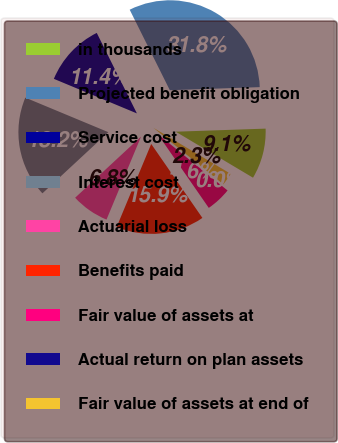Convert chart to OTSL. <chart><loc_0><loc_0><loc_500><loc_500><pie_chart><fcel>in thousands<fcel>Projected benefit obligation<fcel>Service cost<fcel>Interest cost<fcel>Actuarial loss<fcel>Benefits paid<fcel>Fair value of assets at<fcel>Actual return on plan assets<fcel>Fair value of assets at end of<nl><fcel>9.09%<fcel>31.82%<fcel>11.36%<fcel>18.18%<fcel>6.82%<fcel>15.91%<fcel>4.55%<fcel>0.0%<fcel>2.27%<nl></chart> 